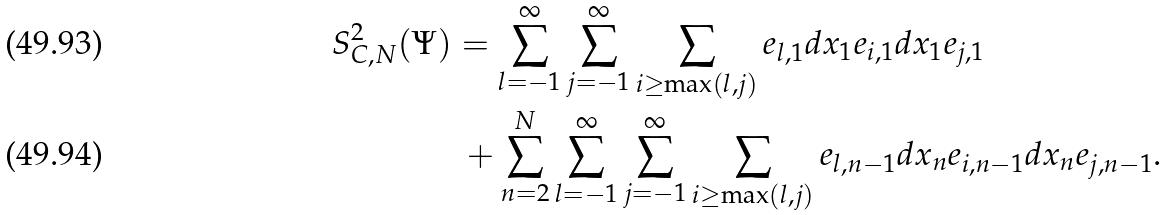<formula> <loc_0><loc_0><loc_500><loc_500>S _ { C , N } ^ { 2 } ( \Psi ) & = \sum ^ { \infty } _ { l = - 1 } \sum ^ { \infty } _ { j = - 1 } \sum _ { i \geq \max ( l , j ) } e _ { l , 1 } d x _ { 1 } e _ { i , 1 } d x _ { 1 } e _ { j , 1 } \\ & \ + \sum ^ { N } _ { n = 2 } \sum ^ { \infty } _ { l = - 1 } \sum ^ { \infty } _ { j = - 1 } \sum _ { i \geq \max ( l , j ) } e _ { l , n - 1 } d x _ { n } e _ { i , n - 1 } d x _ { n } e _ { j , n - 1 } .</formula> 